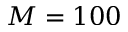<formula> <loc_0><loc_0><loc_500><loc_500>M = 1 0 0</formula> 